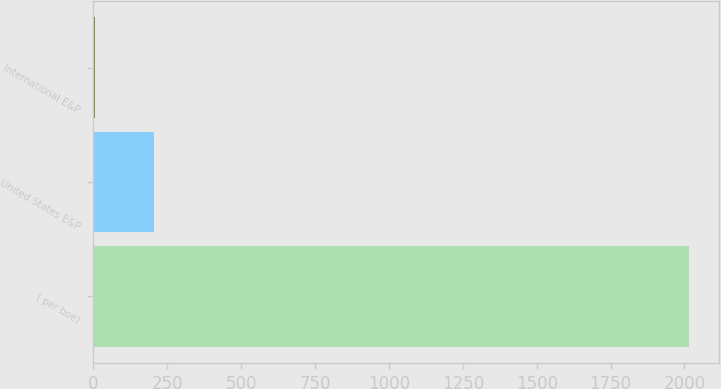Convert chart. <chart><loc_0><loc_0><loc_500><loc_500><bar_chart><fcel>( per boe)<fcel>United States E&P<fcel>International E&P<nl><fcel>2016<fcel>206.15<fcel>5.05<nl></chart> 